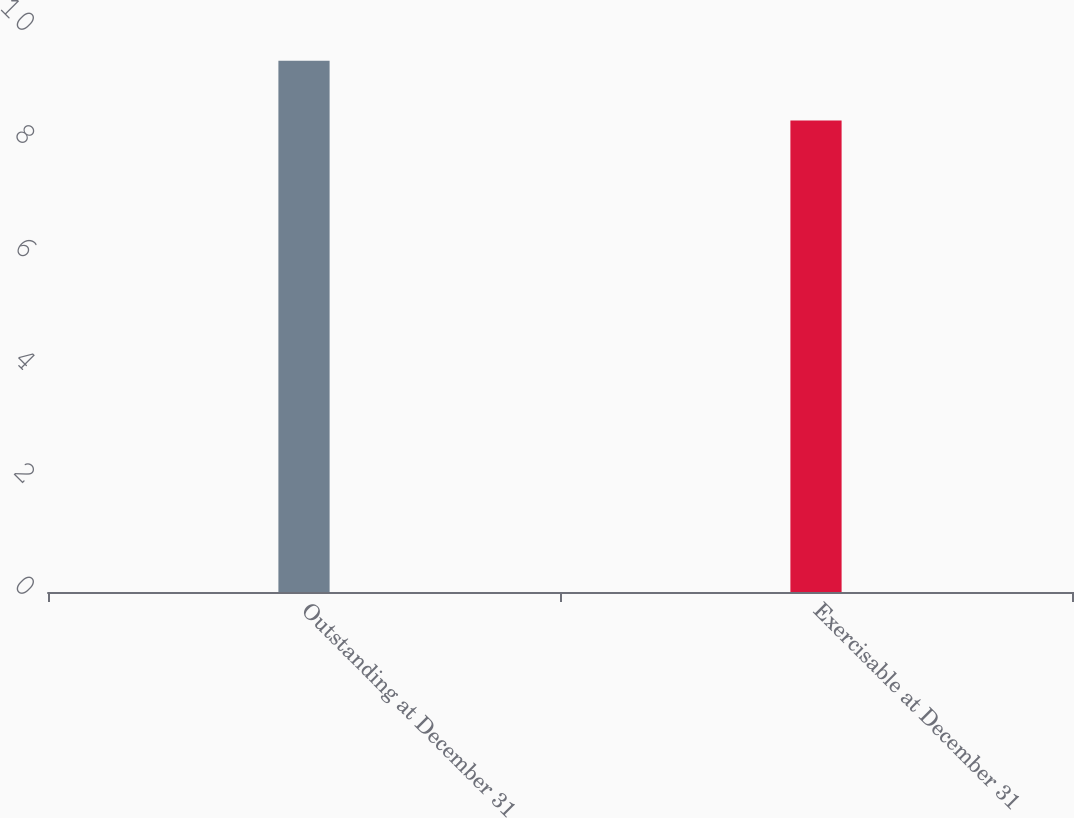Convert chart to OTSL. <chart><loc_0><loc_0><loc_500><loc_500><bar_chart><fcel>Outstanding at December 31<fcel>Exercisable at December 31<nl><fcel>9.42<fcel>8.36<nl></chart> 